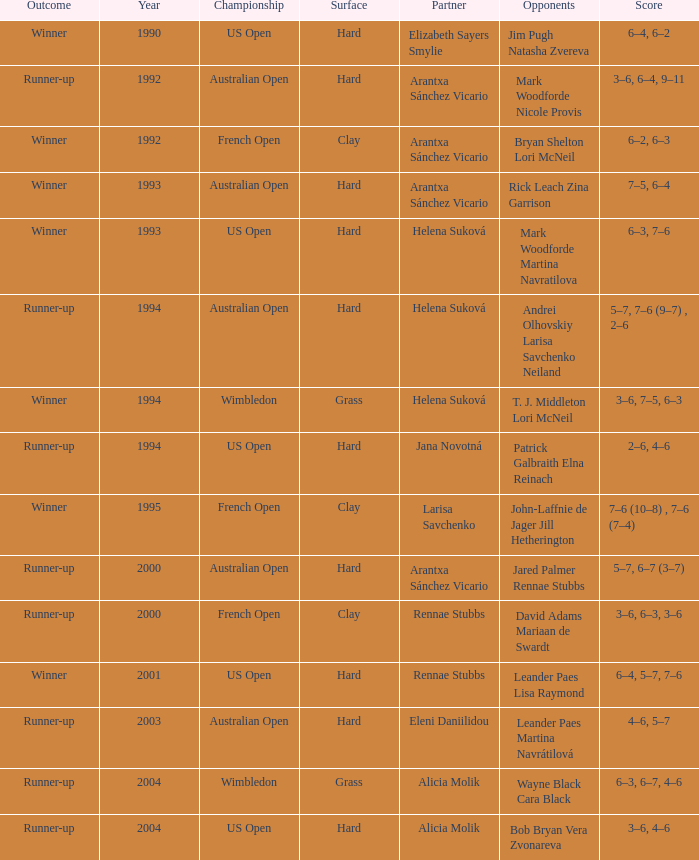Who was the Partner that was a winner, a Year smaller than 1993, and a Score of 6–4, 6–2? Elizabeth Sayers Smylie. 